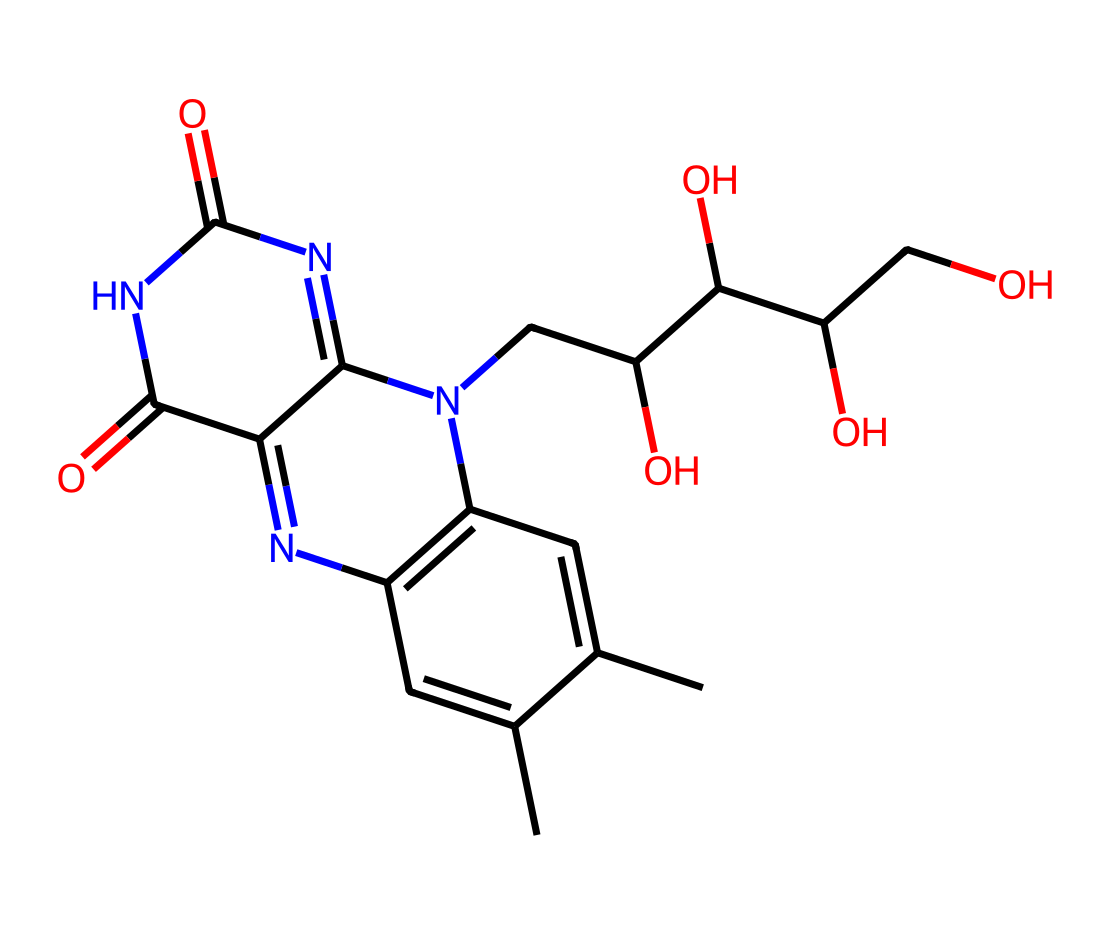What is the molecular formula of riboflavin? To determine the molecular formula, we count the number of each type of atom in the SMILES representation. We identify 17 carbon (C) atoms, 20 hydrogen (H) atoms, 6 nitrogen (N) atoms, and 6 oxygen (O) atoms. Thus, the molecular formula can be written as C17H20N6O6.
Answer: C17H20N6O6 How many nitrogen atoms are present in riboflavin? By analyzing the SMILES representation, we see that the letters 'N' represent nitrogen atoms. There are 6 instances of 'N' in the structure. Hence, riboflavin contains 6 nitrogen atoms.
Answer: 6 What structural feature is characteristic of riboflavin? Riboflavin contains isoalloxazine, which is a bicyclic structure that is prominent in its molecular structure. This feature is a characteristic part of all B vitamins and plays a role in its function as a coenzyme.
Answer: isoalloxazine How many rings are present in the riboflavin molecule? The molecular structure of riboflavin contains multiple interconnected rings. Counting those rings, we find a total of 3 rings in the structure. Therefore, there are 3 rings in riboflavin.
Answer: 3 What functional groups can be identified in riboflavin? The SMILES representation reveals several functional groups, such as carbonyl (C=O) and hydroxyl (–OH) groups. The presence of these groups indicates specific chemical reactivity and contributes to its biological functions.
Answer: carbonyl and hydroxyl groups What is the primary role of riboflavin in the body? Riboflavin is primarily known for its role in energy metabolism, as it is a vital component of coenzymes involved in the metabolism of carbohydrates, fats, and proteins. Thus, its main role is energy metabolism.
Answer: energy metabolism 